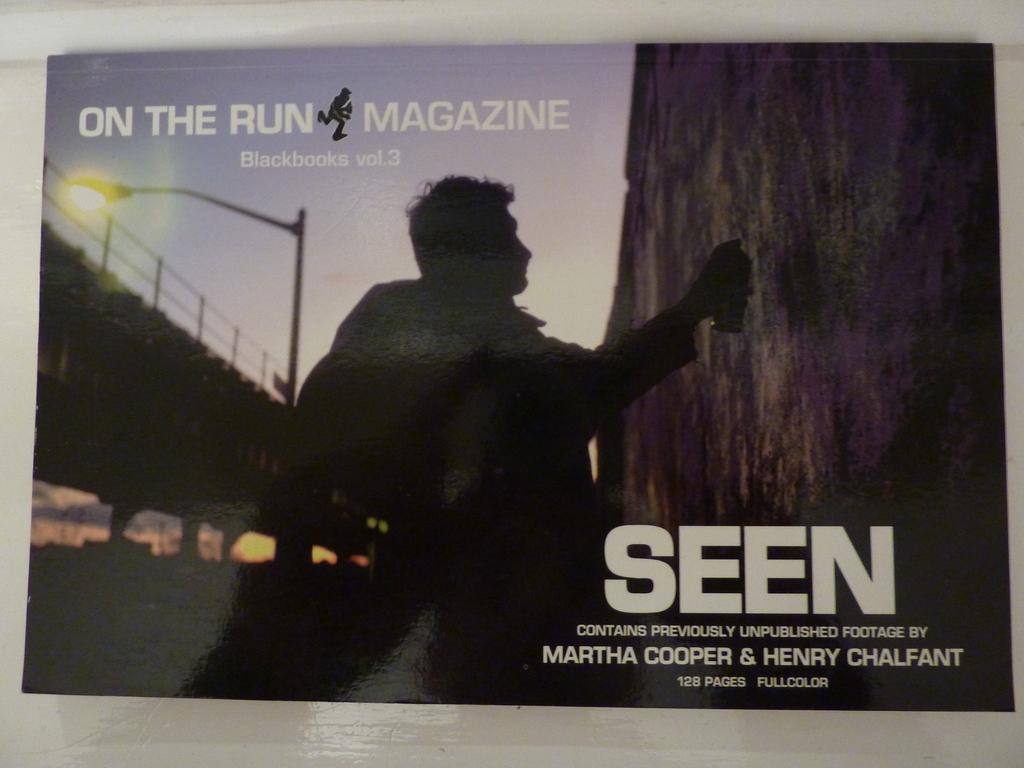In one or two sentences, can you explain what this image depicts? In the center of the image there is a man. On the right side of the there is a wall. On the left side of the image there is a bridge and street light. In the background there is a sky. 